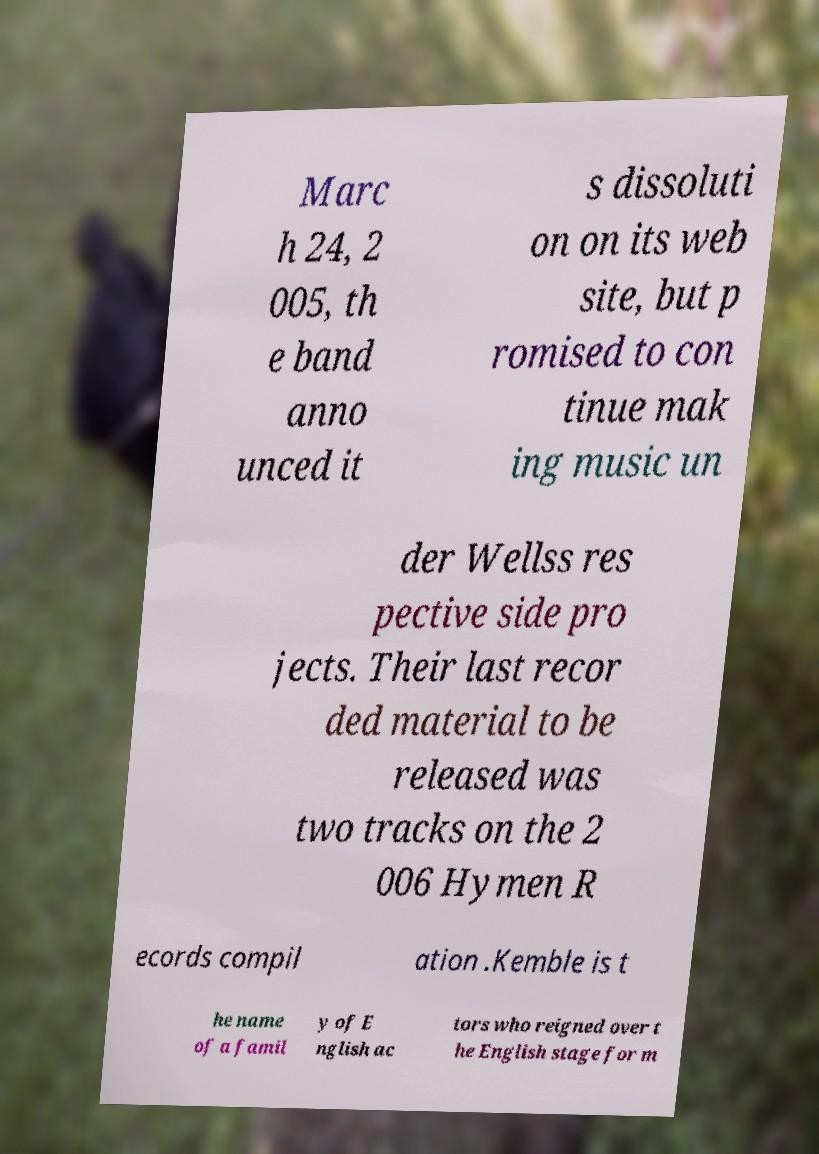Could you extract and type out the text from this image? Marc h 24, 2 005, th e band anno unced it s dissoluti on on its web site, but p romised to con tinue mak ing music un der Wellss res pective side pro jects. Their last recor ded material to be released was two tracks on the 2 006 Hymen R ecords compil ation .Kemble is t he name of a famil y of E nglish ac tors who reigned over t he English stage for m 